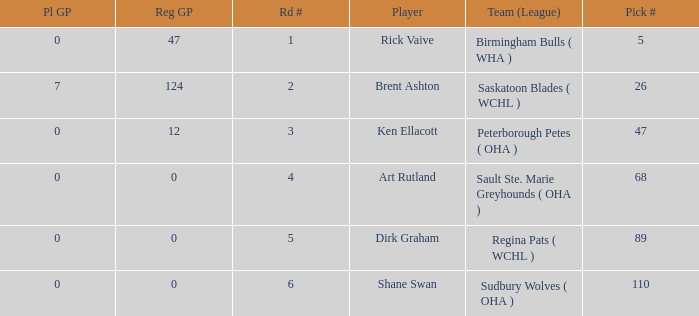How many reg GP for rick vaive in round 1? None. 